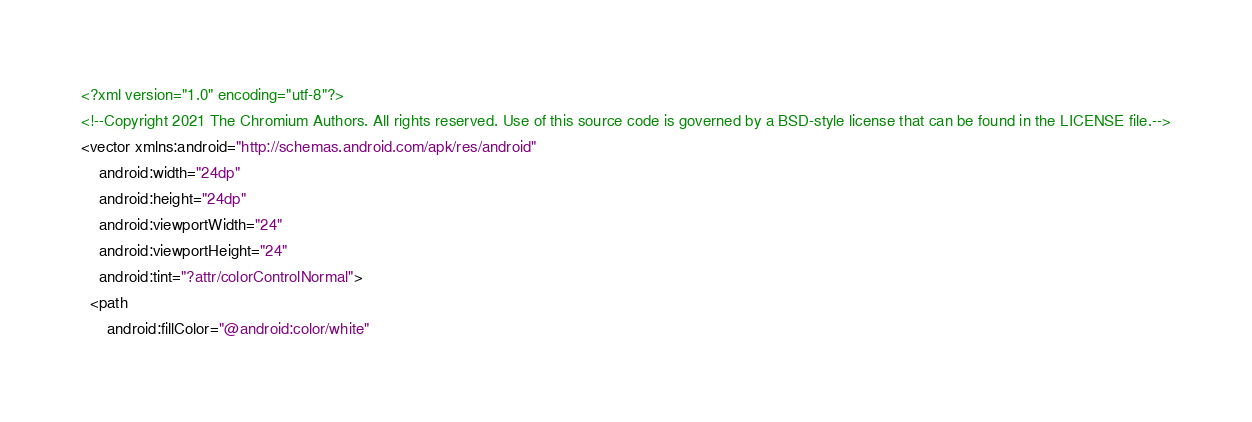<code> <loc_0><loc_0><loc_500><loc_500><_XML_><?xml version="1.0" encoding="utf-8"?>
<!--Copyright 2021 The Chromium Authors. All rights reserved. Use of this source code is governed by a BSD-style license that can be found in the LICENSE file.-->
<vector xmlns:android="http://schemas.android.com/apk/res/android"
    android:width="24dp"
    android:height="24dp"
    android:viewportWidth="24"
    android:viewportHeight="24"
    android:tint="?attr/colorControlNormal">
  <path
      android:fillColor="@android:color/white"</code> 